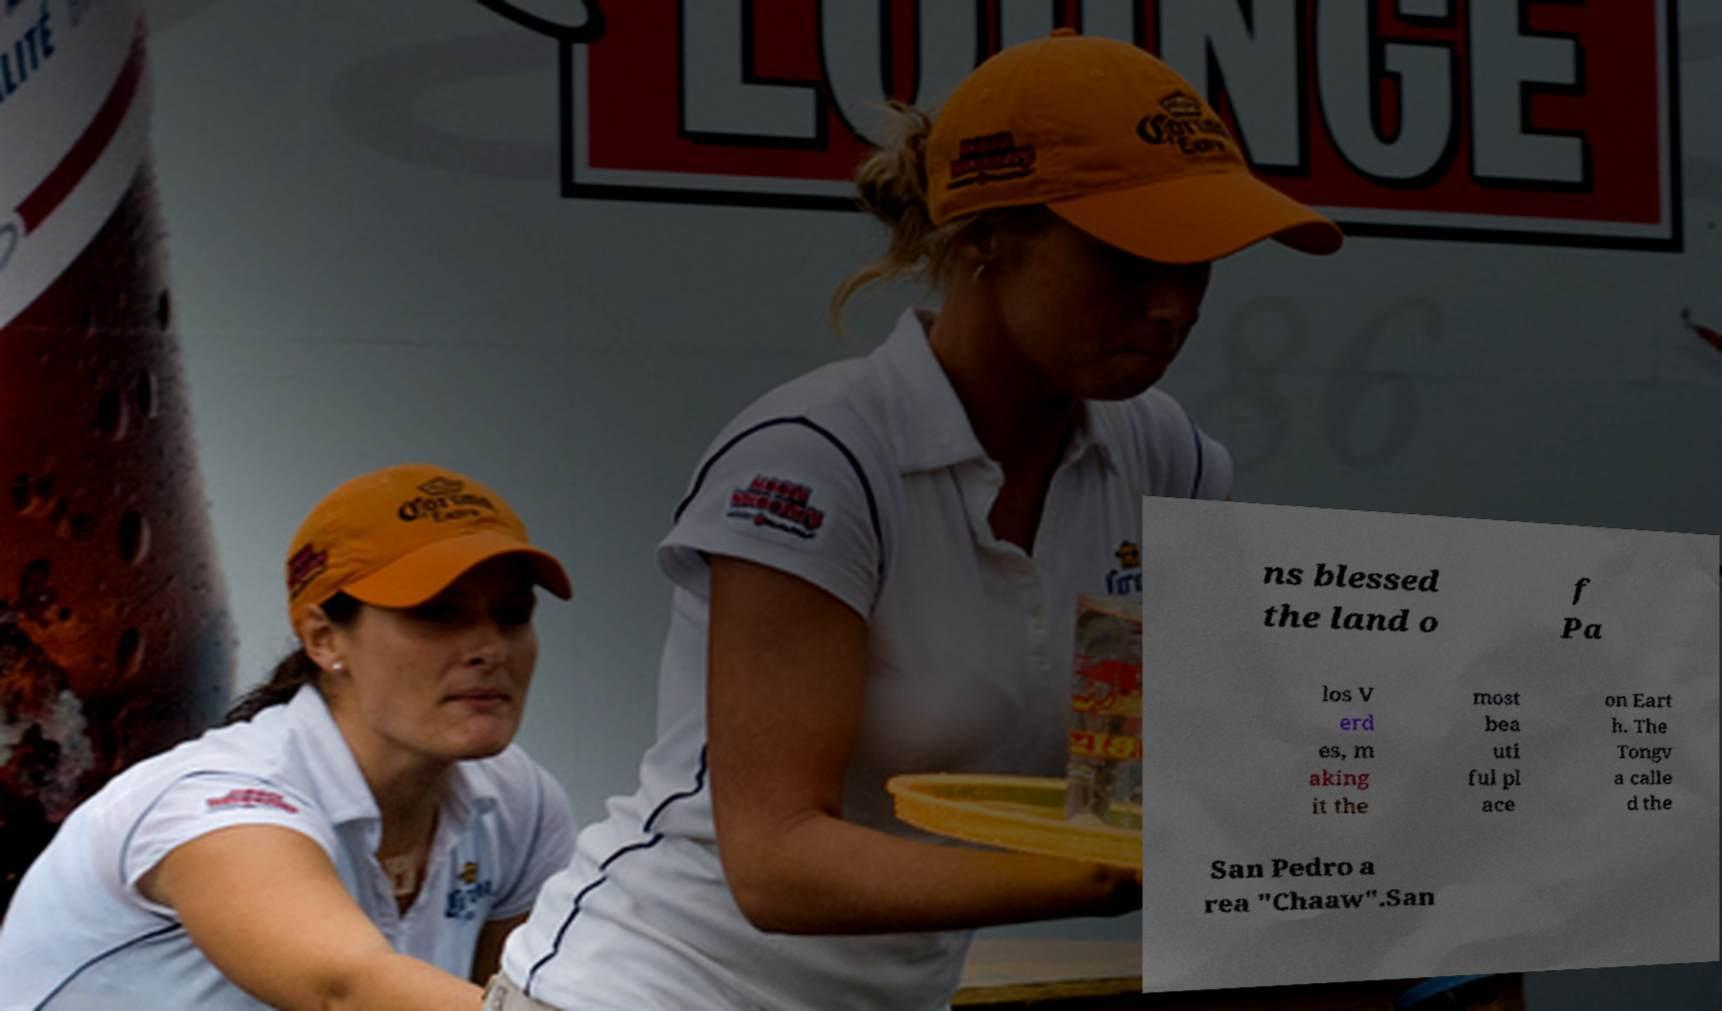There's text embedded in this image that I need extracted. Can you transcribe it verbatim? ns blessed the land o f Pa los V erd es, m aking it the most bea uti ful pl ace on Eart h. The Tongv a calle d the San Pedro a rea "Chaaw".San 